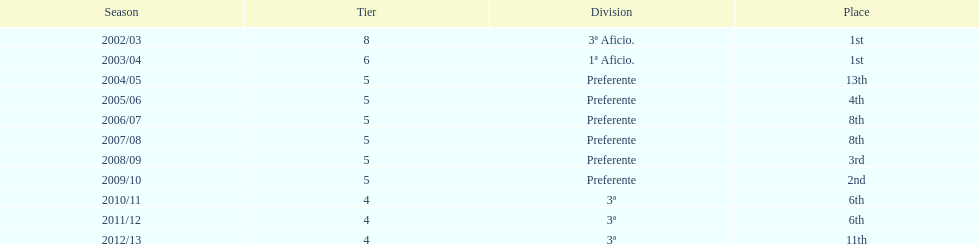Over how many years was the team part of the 3 a division? 4. 